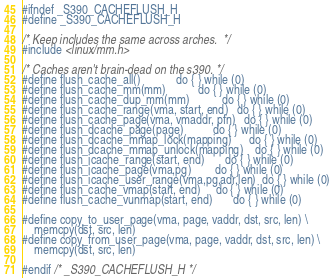Convert code to text. <code><loc_0><loc_0><loc_500><loc_500><_C_>#ifndef _S390_CACHEFLUSH_H
#define _S390_CACHEFLUSH_H

/* Keep includes the same across arches.  */
#include <linux/mm.h>

/* Caches aren't brain-dead on the s390. */
#define flush_cache_all()			do { } while (0)
#define flush_cache_mm(mm)			do { } while (0)
#define flush_cache_dup_mm(mm)			do { } while (0)
#define flush_cache_range(vma, start, end)	do { } while (0)
#define flush_cache_page(vma, vmaddr, pfn)	do { } while (0)
#define flush_dcache_page(page)			do { } while (0)
#define flush_dcache_mmap_lock(mapping)		do { } while (0)
#define flush_dcache_mmap_unlock(mapping)	do { } while (0)
#define flush_icache_range(start, end)		do { } while (0)
#define flush_icache_page(vma,pg)		do { } while (0)
#define flush_icache_user_range(vma,pg,adr,len)	do { } while (0)
#define flush_cache_vmap(start, end)		do { } while (0)
#define flush_cache_vunmap(start, end)		do { } while (0)

#define copy_to_user_page(vma, page, vaddr, dst, src, len) \
	memcpy(dst, src, len)
#define copy_from_user_page(vma, page, vaddr, dst, src, len) \
	memcpy(dst, src, len)

#endif /* _S390_CACHEFLUSH_H */
</code> 